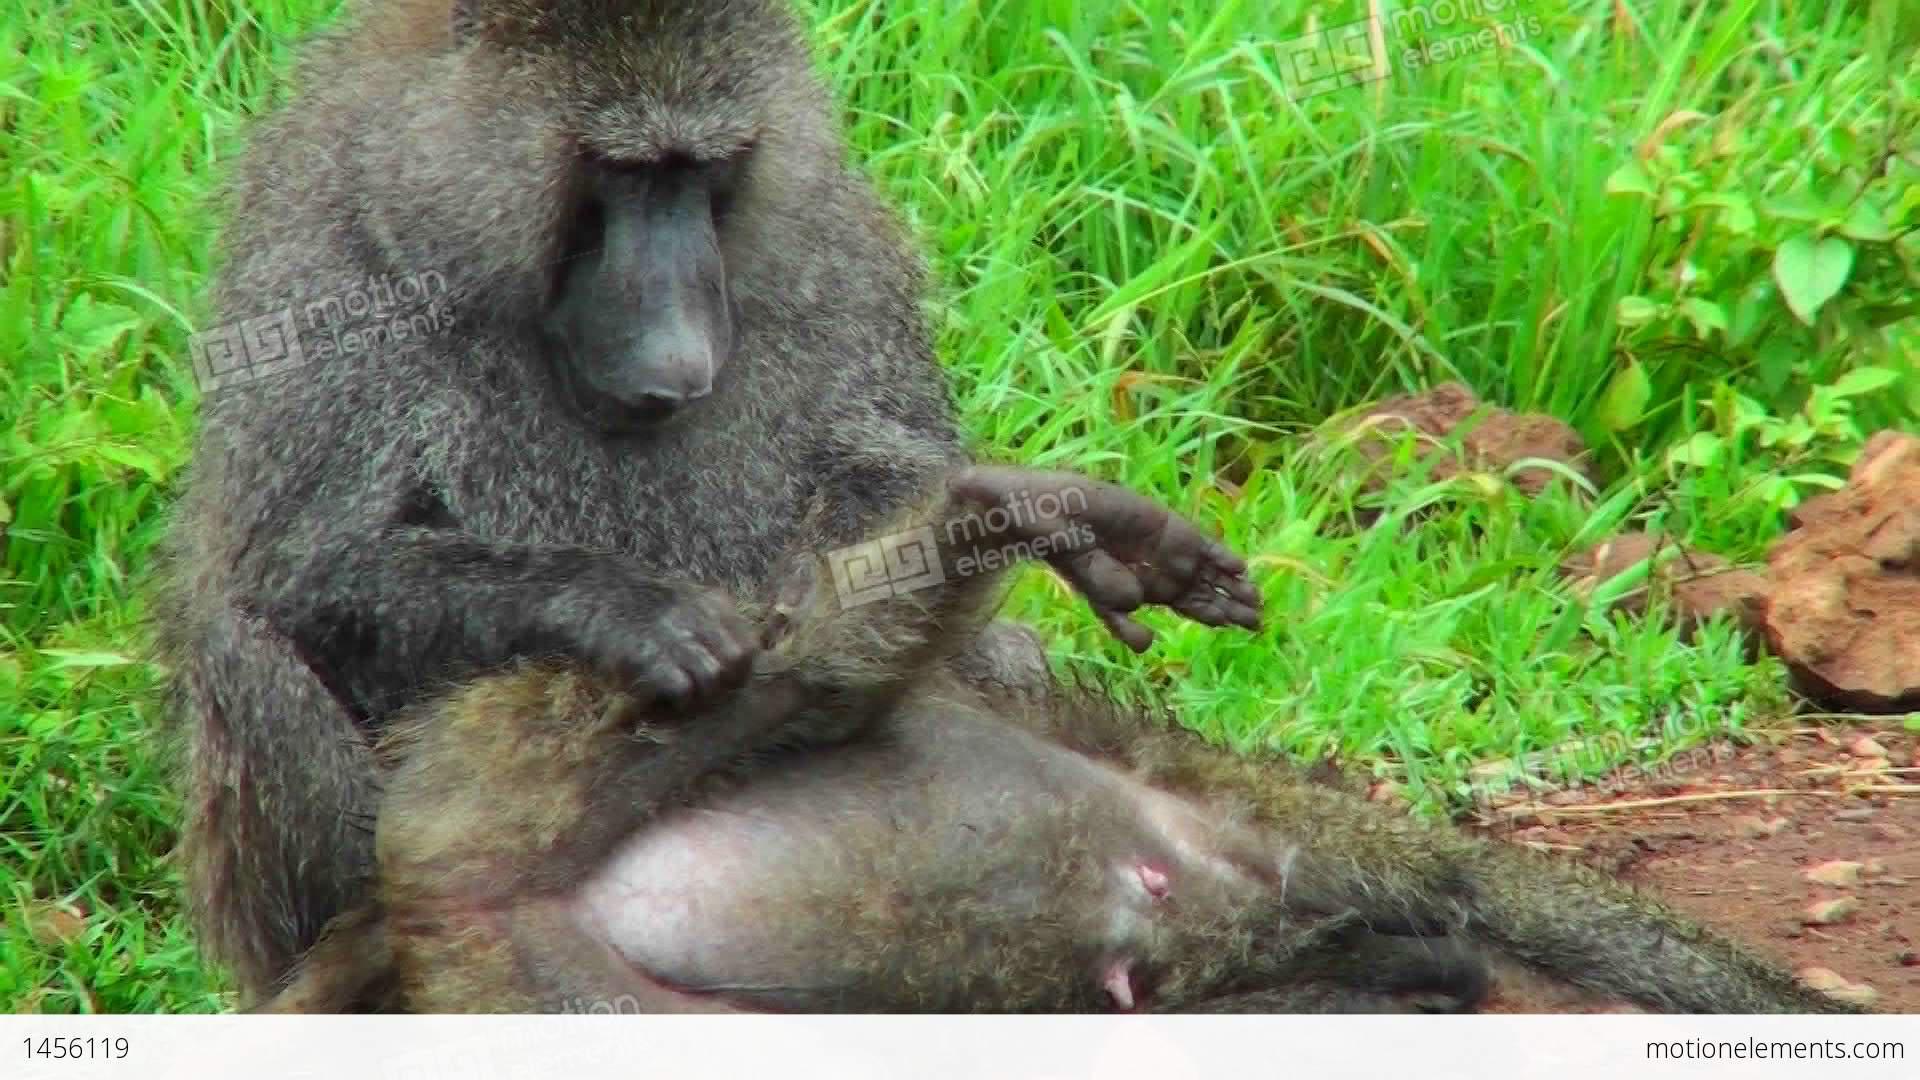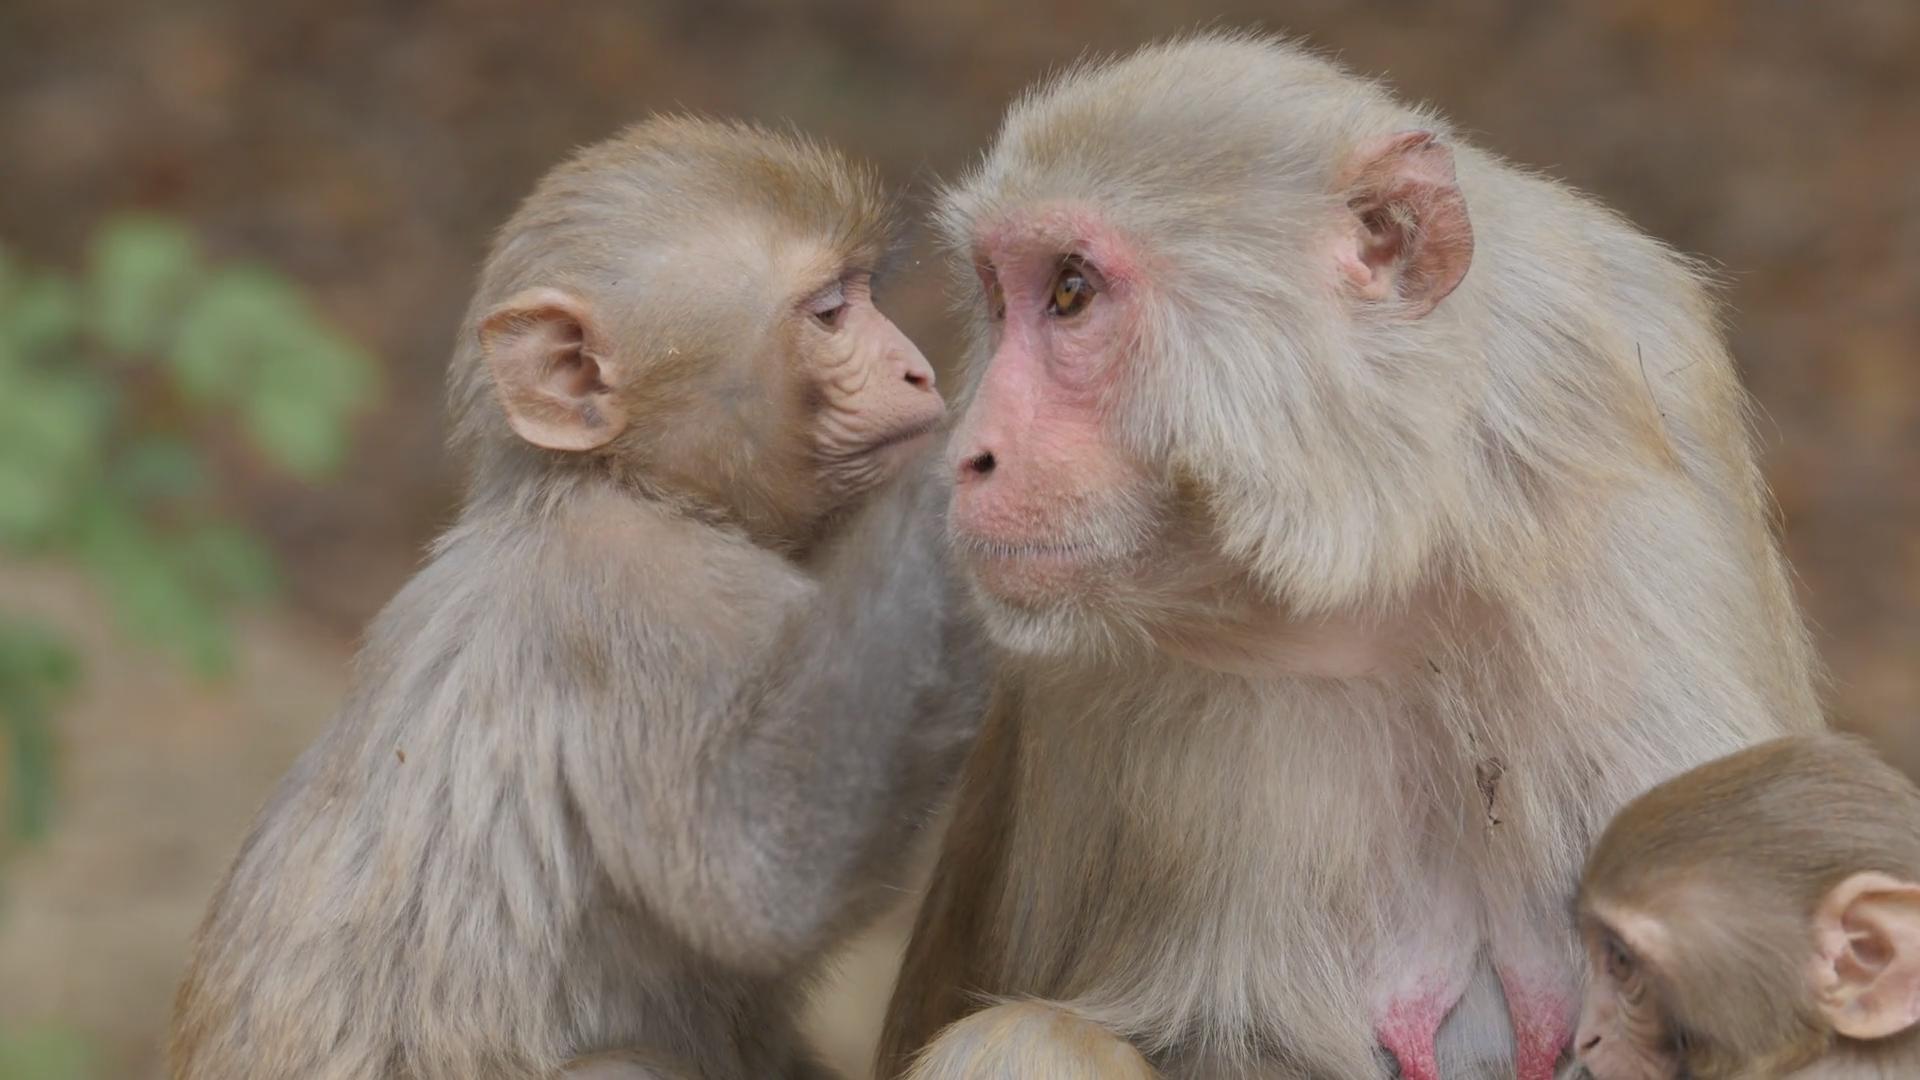The first image is the image on the left, the second image is the image on the right. For the images shown, is this caption "There are exactly four apes." true? Answer yes or no. No. The first image is the image on the left, the second image is the image on the right. Assess this claim about the two images: "a baboon is grooming another baboon's leg while it lays down". Correct or not? Answer yes or no. Yes. 